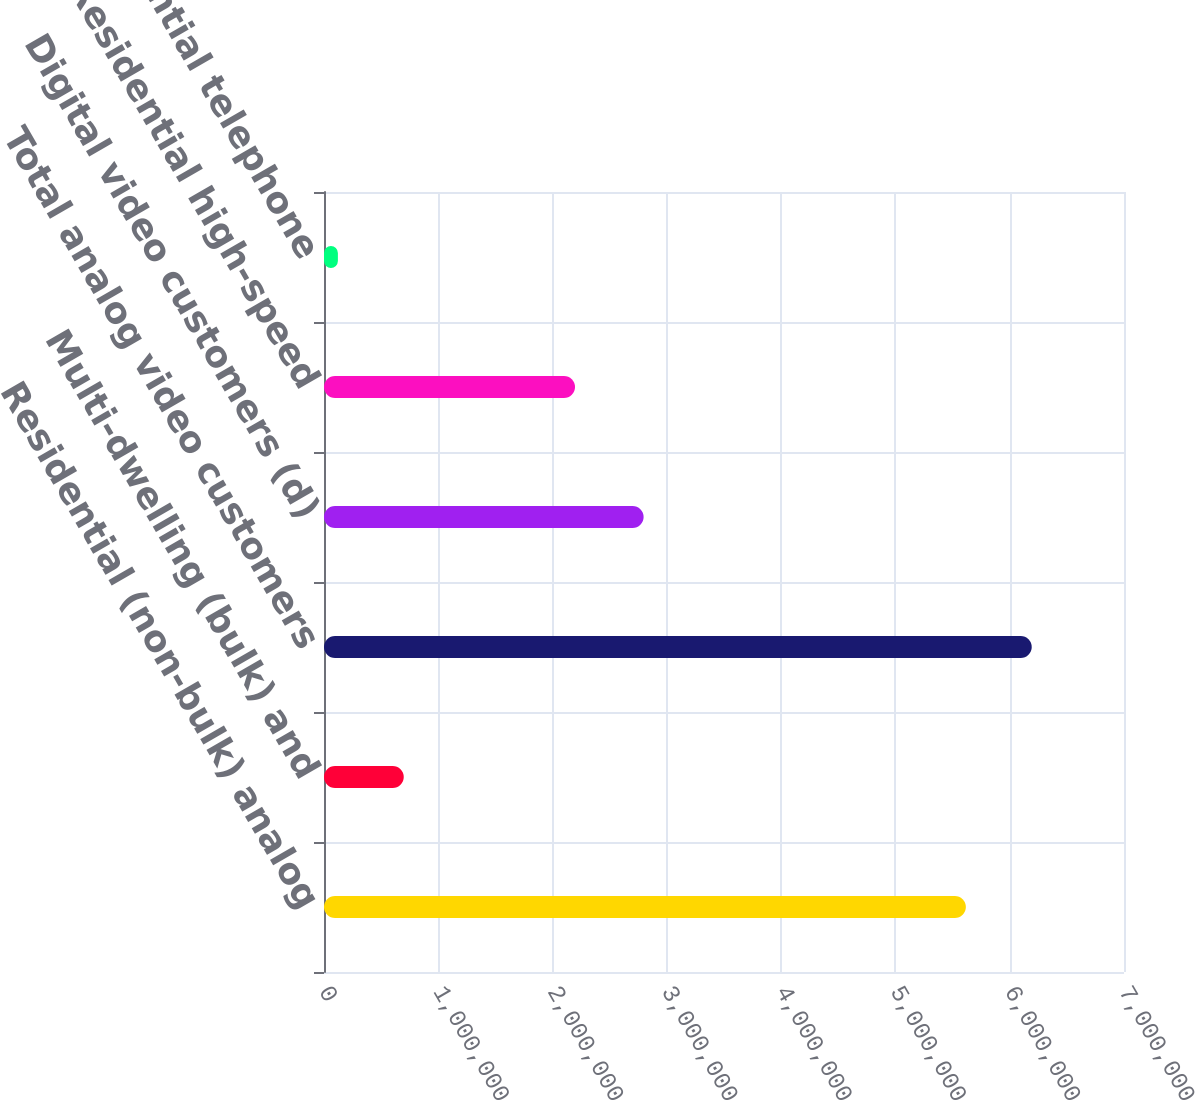Convert chart. <chart><loc_0><loc_0><loc_500><loc_500><bar_chart><fcel>Residential (non-bulk) analog<fcel>Multi-dwelling (bulk) and<fcel>Total analog video customers<fcel>Digital video customers (d)<fcel>Residential high-speed<fcel>Residential telephone<nl><fcel>5.6163e+06<fcel>697800<fcel>6.1926e+06<fcel>2.7966e+06<fcel>2.1964e+06<fcel>121500<nl></chart> 